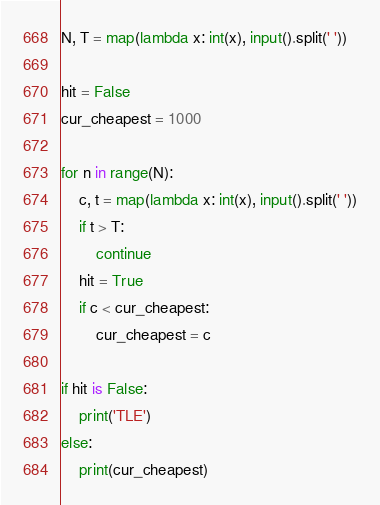Convert code to text. <code><loc_0><loc_0><loc_500><loc_500><_Python_>N, T = map(lambda x: int(x), input().split(' '))

hit = False
cur_cheapest = 1000

for n in range(N):
    c, t = map(lambda x: int(x), input().split(' '))
    if t > T:
        continue
    hit = True
    if c < cur_cheapest:
        cur_cheapest = c

if hit is False:
    print('TLE')
else:
    print(cur_cheapest)</code> 